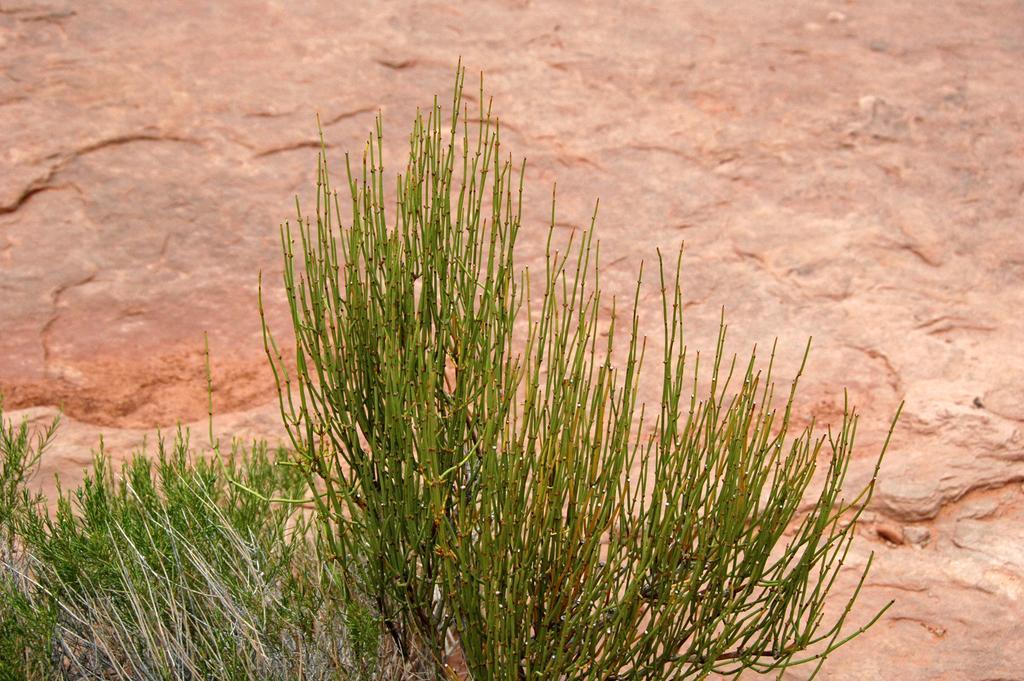In one or two sentences, can you explain what this image depicts? In this image I can see there are a few plants and in the backdrop there is a huge rock. 